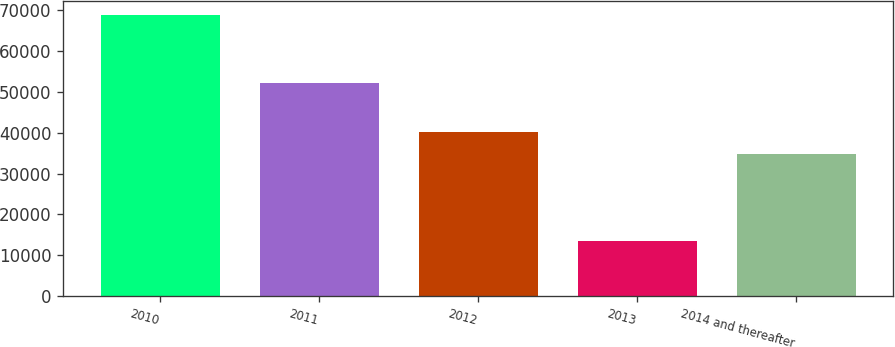Convert chart to OTSL. <chart><loc_0><loc_0><loc_500><loc_500><bar_chart><fcel>2010<fcel>2011<fcel>2012<fcel>2013<fcel>2014 and thereafter<nl><fcel>68763<fcel>52251<fcel>40291.9<fcel>13554<fcel>34771<nl></chart> 